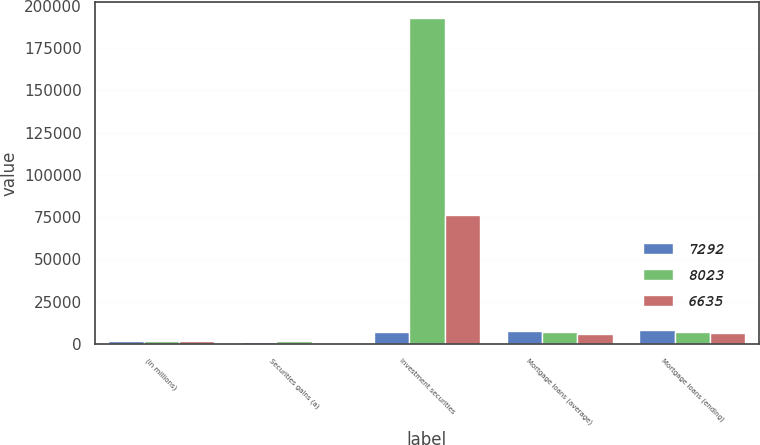Convert chart to OTSL. <chart><loc_0><loc_0><loc_500><loc_500><stacked_bar_chart><ecel><fcel>(in millions)<fcel>Securities gains (a)<fcel>Investment securities<fcel>Mortgage loans (average)<fcel>Mortgage loans (ending)<nl><fcel>7292<fcel>2009<fcel>1147<fcel>6847<fcel>7427<fcel>8023<nl><fcel>8023<fcel>2008<fcel>1652<fcel>192564<fcel>7059<fcel>7292<nl><fcel>6635<fcel>2007<fcel>37<fcel>76480<fcel>5639<fcel>6635<nl></chart> 